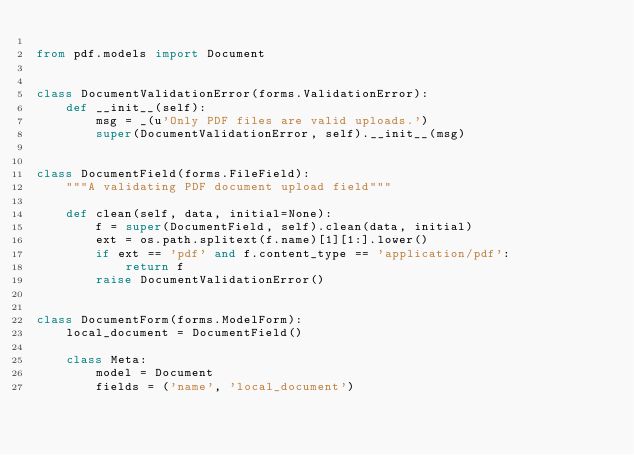<code> <loc_0><loc_0><loc_500><loc_500><_Python_>
from pdf.models import Document


class DocumentValidationError(forms.ValidationError):
    def __init__(self):
        msg = _(u'Only PDF files are valid uploads.')
        super(DocumentValidationError, self).__init__(msg)


class DocumentField(forms.FileField):
    """A validating PDF document upload field"""

    def clean(self, data, initial=None):
        f = super(DocumentField, self).clean(data, initial)
        ext = os.path.splitext(f.name)[1][1:].lower()
        if ext == 'pdf' and f.content_type == 'application/pdf':
            return f
        raise DocumentValidationError()


class DocumentForm(forms.ModelForm):
    local_document = DocumentField()

    class Meta:
        model = Document
        fields = ('name', 'local_document')
</code> 